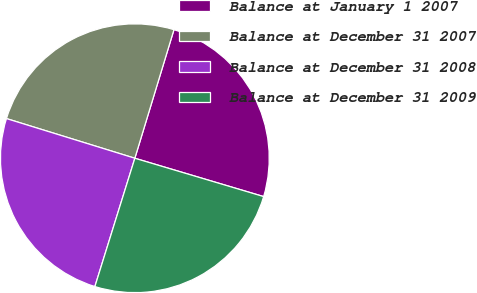<chart> <loc_0><loc_0><loc_500><loc_500><pie_chart><fcel>Balance at January 1 2007<fcel>Balance at December 31 2007<fcel>Balance at December 31 2008<fcel>Balance at December 31 2009<nl><fcel>24.9%<fcel>24.93%<fcel>24.96%<fcel>25.2%<nl></chart> 